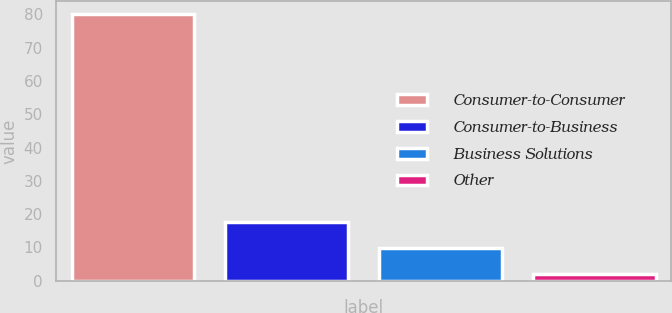Convert chart to OTSL. <chart><loc_0><loc_0><loc_500><loc_500><bar_chart><fcel>Consumer-to-Consumer<fcel>Consumer-to-Business<fcel>Business Solutions<fcel>Other<nl><fcel>80<fcel>17.6<fcel>9.8<fcel>2<nl></chart> 